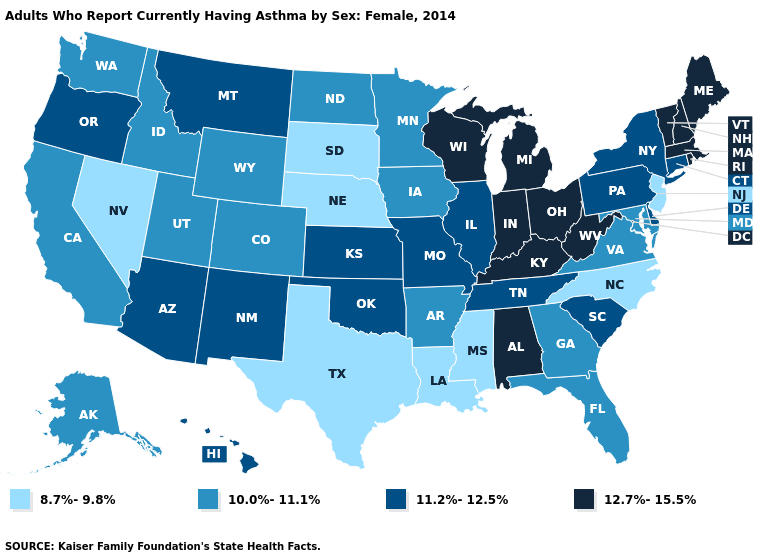What is the value of Michigan?
Write a very short answer. 12.7%-15.5%. What is the lowest value in the Northeast?
Write a very short answer. 8.7%-9.8%. Does Louisiana have a lower value than Massachusetts?
Concise answer only. Yes. Name the states that have a value in the range 10.0%-11.1%?
Give a very brief answer. Alaska, Arkansas, California, Colorado, Florida, Georgia, Idaho, Iowa, Maryland, Minnesota, North Dakota, Utah, Virginia, Washington, Wyoming. Among the states that border Kansas , does Colorado have the highest value?
Short answer required. No. Does the first symbol in the legend represent the smallest category?
Write a very short answer. Yes. Does South Dakota have a higher value than Illinois?
Answer briefly. No. Does Massachusetts have the highest value in the USA?
Quick response, please. Yes. What is the lowest value in the USA?
Keep it brief. 8.7%-9.8%. Name the states that have a value in the range 8.7%-9.8%?
Write a very short answer. Louisiana, Mississippi, Nebraska, Nevada, New Jersey, North Carolina, South Dakota, Texas. Does the first symbol in the legend represent the smallest category?
Write a very short answer. Yes. What is the value of North Carolina?
Concise answer only. 8.7%-9.8%. What is the lowest value in the USA?
Keep it brief. 8.7%-9.8%. What is the highest value in the USA?
Short answer required. 12.7%-15.5%. Name the states that have a value in the range 8.7%-9.8%?
Be succinct. Louisiana, Mississippi, Nebraska, Nevada, New Jersey, North Carolina, South Dakota, Texas. 